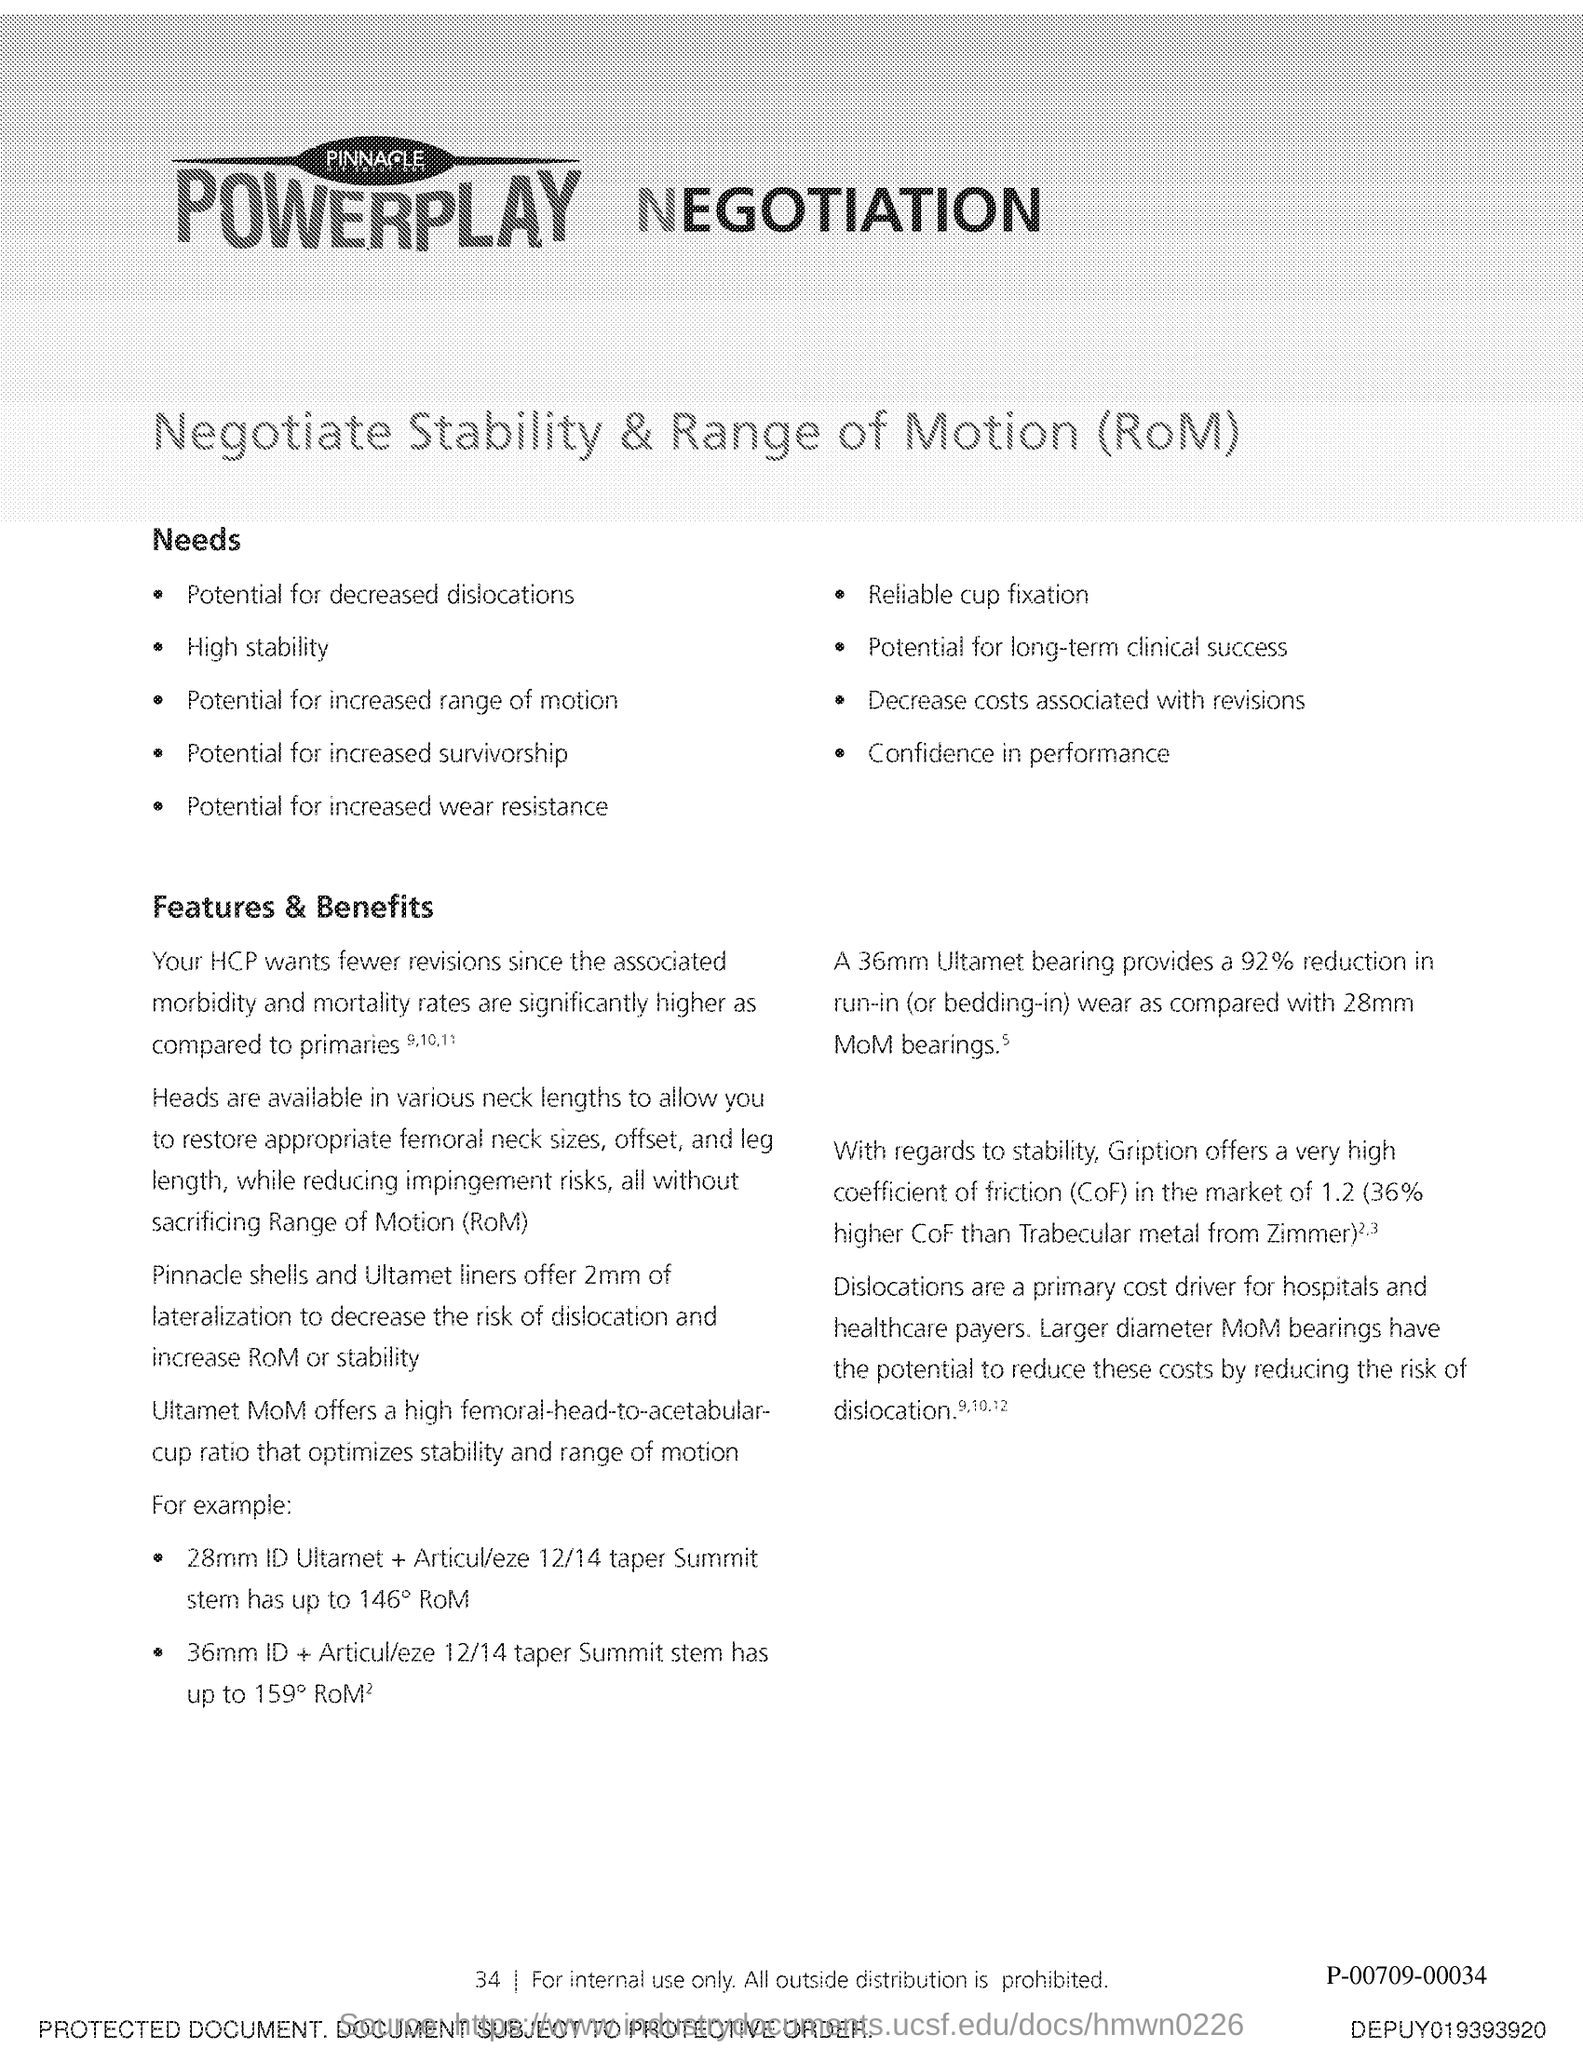Point out several critical features in this image. The term CoF stands for coefficient of friction, which refers to the force that opposes the motion of two surfaces in contact. Range of Motion" is a term commonly used in physical therapy and exercise science to refer to the degree of movement available at a joint or group of joints. 